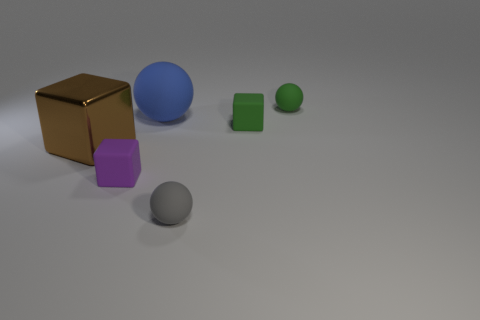Subtract all tiny rubber blocks. How many blocks are left? 1 Add 2 small things. How many objects exist? 8 Subtract all large red rubber cubes. Subtract all small rubber objects. How many objects are left? 2 Add 1 large matte spheres. How many large matte spheres are left? 2 Add 4 tiny purple blocks. How many tiny purple blocks exist? 5 Subtract 1 purple blocks. How many objects are left? 5 